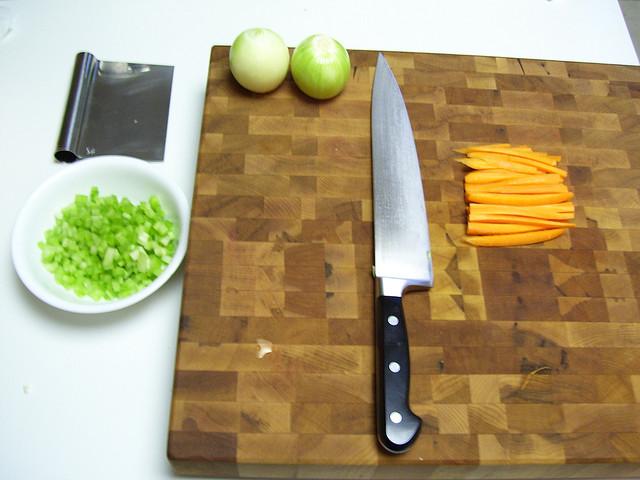How many carrots are there?
Concise answer only. Several. Are the carrots sliced?
Short answer required. Yes. Is the carrot chopped?
Concise answer only. Yes. What color is the knife handle?
Be succinct. Black. What is the purpose of the square metal thing next to the bowl?
Give a very brief answer. Chopping. 